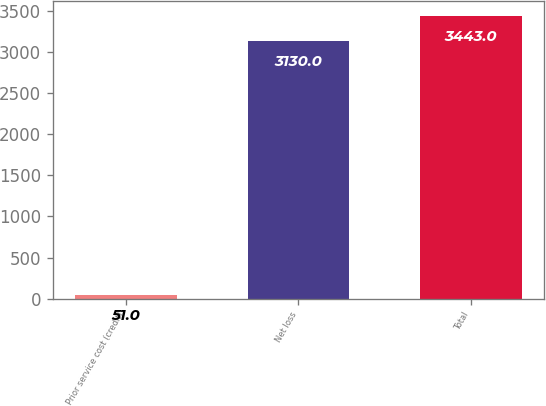Convert chart to OTSL. <chart><loc_0><loc_0><loc_500><loc_500><bar_chart><fcel>Prior service cost (credit)<fcel>Net loss<fcel>Total<nl><fcel>51<fcel>3130<fcel>3443<nl></chart> 